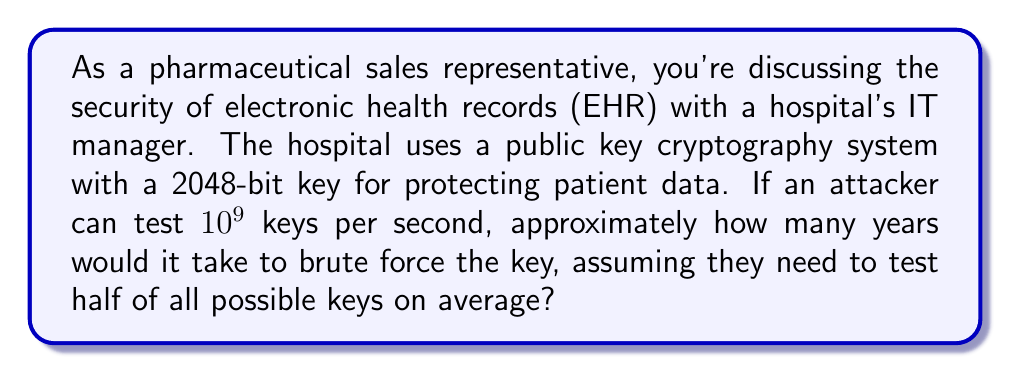Can you solve this math problem? Let's approach this step-by-step:

1) A 2048-bit key means there are $2^{2048}$ possible keys.

2) On average, an attacker would need to test half of these keys to find the correct one:
   $$\frac{2^{2048}}{2} = 2^{2047}$$

3) The attacker can test $10^9$ keys per second. To find the number of seconds needed:
   $$\text{Seconds} = \frac{2^{2047}}{10^9}$$

4) Convert this to years:
   $$\text{Years} = \frac{2^{2047}}{10^9 \times 60 \times 60 \times 24 \times 365.25}$$

5) Simplify:
   $$\text{Years} = \frac{2^{2047}}{31,556,952,000,000}$$

6) Calculate:
   $$\text{Years} \approx 1.3 \times 10^{307}$$

This number is astronomically large, far exceeding the age of the universe (approximately $1.38 \times 10^{10}$ years).
Answer: $1.3 \times 10^{307}$ years 